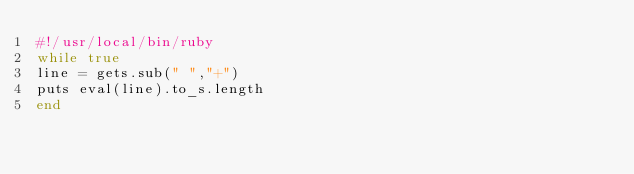<code> <loc_0><loc_0><loc_500><loc_500><_Ruby_>#!/usr/local/bin/ruby
while true
line = gets.sub(" ","+")
puts eval(line).to_s.length
end</code> 